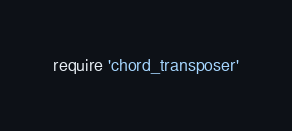<code> <loc_0><loc_0><loc_500><loc_500><_Ruby_>require 'chord_transposer'</code> 